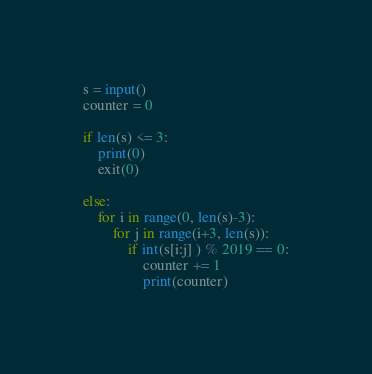Convert code to text. <code><loc_0><loc_0><loc_500><loc_500><_Python_>s = input()
counter = 0
 
if len(s) <= 3:
    print(0)
    exit(0)
 
else:
    for i in range(0, len(s)-3):
        for j in range(i+3, len(s)):
            if int(s[i:j] ) % 2019 == 0:
                counter += 1
                print(counter)</code> 